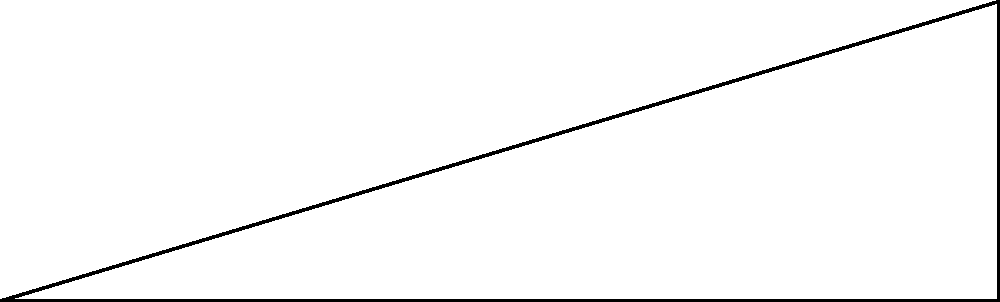At a peaceful demonstration, an observer wants to calculate the height of a protest banner. Standing 30 meters away from the base of the banner, the observer measures the angle of elevation to the top of the banner to be 35°. Using trigonometry, what is the approximate height of the banner to the nearest tenth of a meter? Let's approach this step-by-step:

1) We can model this situation as a right triangle, where:
   - The observer is at point A
   - The base of the banner is at point B
   - The top of the banner is at point C

2) We know:
   - The angle of elevation: $\theta = 35°$
   - The distance from the observer to the base of the banner: $AB = 30$ m
   - We need to find the height of the banner: $BC$

3) In this right triangle, we can use the tangent function:

   $\tan \theta = \frac{\text{opposite}}{\text{adjacent}} = \frac{BC}{AB}$

4) Substituting the known values:

   $\tan 35° = \frac{BC}{30}$

5) To solve for $BC$, multiply both sides by 30:

   $BC = 30 \tan 35°$

6) Using a calculator (or trigonometric tables):

   $BC = 30 \times 0.7002 = 21.006$ m

7) Rounding to the nearest tenth:

   $BC \approx 21.0$ m

Therefore, the height of the banner is approximately 21.0 meters.
Answer: 21.0 m 